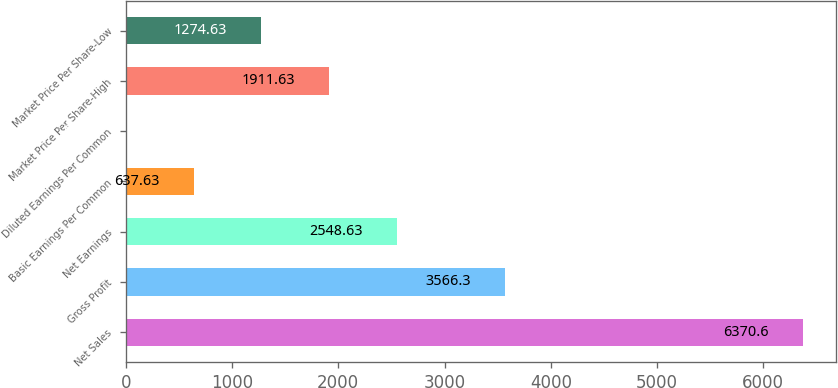<chart> <loc_0><loc_0><loc_500><loc_500><bar_chart><fcel>Net Sales<fcel>Gross Profit<fcel>Net Earnings<fcel>Basic Earnings Per Common<fcel>Diluted Earnings Per Common<fcel>Market Price Per Share-High<fcel>Market Price Per Share-Low<nl><fcel>6370.6<fcel>3566.3<fcel>2548.63<fcel>637.63<fcel>0.63<fcel>1911.63<fcel>1274.63<nl></chart> 